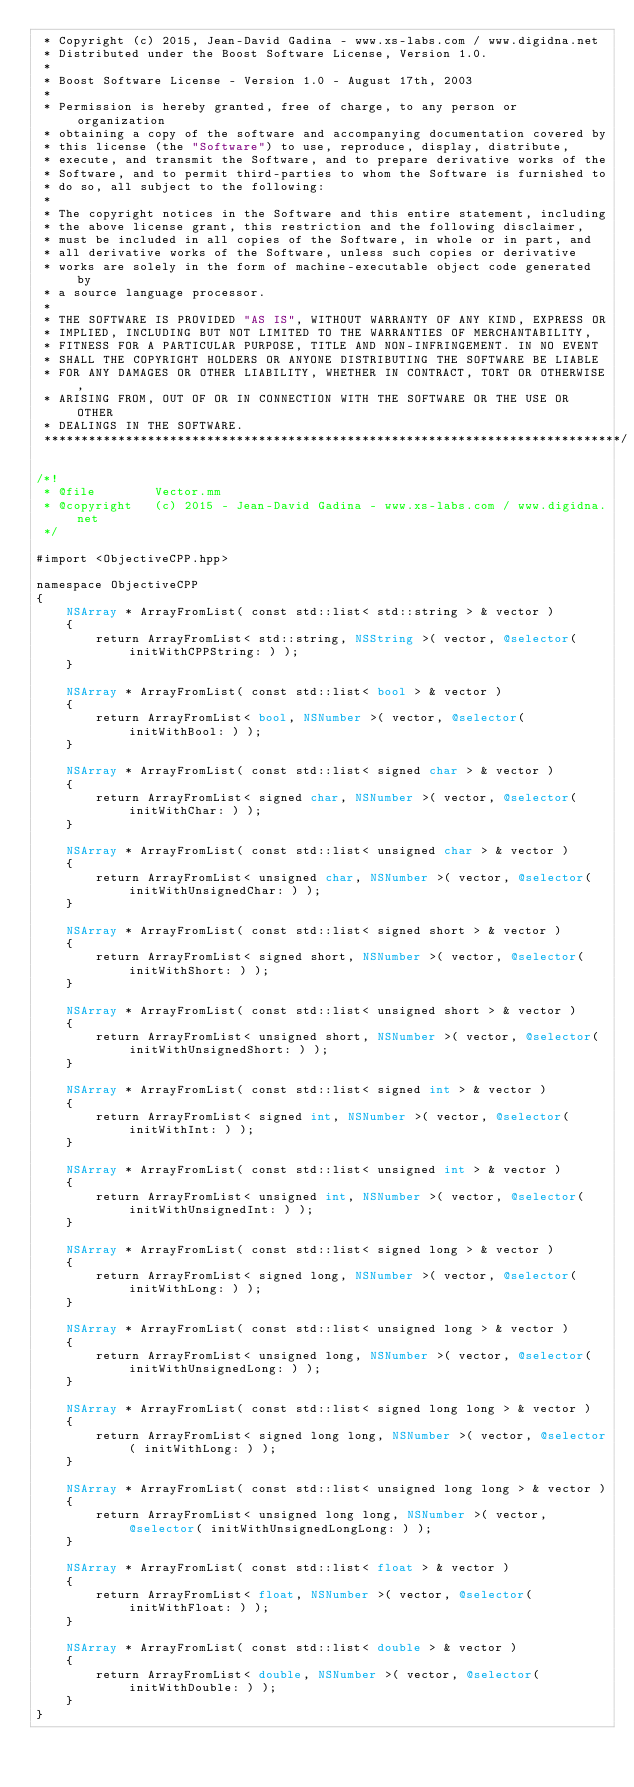<code> <loc_0><loc_0><loc_500><loc_500><_ObjectiveC_> * Copyright (c) 2015, Jean-David Gadina - www.xs-labs.com / www.digidna.net
 * Distributed under the Boost Software License, Version 1.0.
 * 
 * Boost Software License - Version 1.0 - August 17th, 2003
 * 
 * Permission is hereby granted, free of charge, to any person or organization
 * obtaining a copy of the software and accompanying documentation covered by
 * this license (the "Software") to use, reproduce, display, distribute,
 * execute, and transmit the Software, and to prepare derivative works of the
 * Software, and to permit third-parties to whom the Software is furnished to
 * do so, all subject to the following:
 * 
 * The copyright notices in the Software and this entire statement, including
 * the above license grant, this restriction and the following disclaimer,
 * must be included in all copies of the Software, in whole or in part, and
 * all derivative works of the Software, unless such copies or derivative
 * works are solely in the form of machine-executable object code generated by
 * a source language processor.
 * 
 * THE SOFTWARE IS PROVIDED "AS IS", WITHOUT WARRANTY OF ANY KIND, EXPRESS OR
 * IMPLIED, INCLUDING BUT NOT LIMITED TO THE WARRANTIES OF MERCHANTABILITY,
 * FITNESS FOR A PARTICULAR PURPOSE, TITLE AND NON-INFRINGEMENT. IN NO EVENT
 * SHALL THE COPYRIGHT HOLDERS OR ANYONE DISTRIBUTING THE SOFTWARE BE LIABLE
 * FOR ANY DAMAGES OR OTHER LIABILITY, WHETHER IN CONTRACT, TORT OR OTHERWISE,
 * ARISING FROM, OUT OF OR IN CONNECTION WITH THE SOFTWARE OR THE USE OR OTHER
 * DEALINGS IN THE SOFTWARE.
 ******************************************************************************/

/*!
 * @file        Vector.mm
 * @copyright   (c) 2015 - Jean-David Gadina - www.xs-labs.com / www.digidna.net
 */

#import <ObjectiveCPP.hpp>

namespace ObjectiveCPP
{
    NSArray * ArrayFromList( const std::list< std::string > & vector )
    {
        return ArrayFromList< std::string, NSString >( vector, @selector( initWithCPPString: ) );
    }
    
    NSArray * ArrayFromList( const std::list< bool > & vector )
    {
        return ArrayFromList< bool, NSNumber >( vector, @selector( initWithBool: ) );
    }
    
    NSArray * ArrayFromList( const std::list< signed char > & vector )
    {
        return ArrayFromList< signed char, NSNumber >( vector, @selector( initWithChar: ) );
    }
    
    NSArray * ArrayFromList( const std::list< unsigned char > & vector )
    {
        return ArrayFromList< unsigned char, NSNumber >( vector, @selector( initWithUnsignedChar: ) );
    }
    
    NSArray * ArrayFromList( const std::list< signed short > & vector )
    {
        return ArrayFromList< signed short, NSNumber >( vector, @selector( initWithShort: ) );
    }
    
    NSArray * ArrayFromList( const std::list< unsigned short > & vector )
    {
        return ArrayFromList< unsigned short, NSNumber >( vector, @selector( initWithUnsignedShort: ) );
    }
    
    NSArray * ArrayFromList( const std::list< signed int > & vector )
    {
        return ArrayFromList< signed int, NSNumber >( vector, @selector( initWithInt: ) );
    }
    
    NSArray * ArrayFromList( const std::list< unsigned int > & vector )
    {
        return ArrayFromList< unsigned int, NSNumber >( vector, @selector( initWithUnsignedInt: ) );
    }
    
    NSArray * ArrayFromList( const std::list< signed long > & vector )
    {
        return ArrayFromList< signed long, NSNumber >( vector, @selector( initWithLong: ) );
    }
    
    NSArray * ArrayFromList( const std::list< unsigned long > & vector )
    {
        return ArrayFromList< unsigned long, NSNumber >( vector, @selector( initWithUnsignedLong: ) );
    }
    
    NSArray * ArrayFromList( const std::list< signed long long > & vector )
    {
        return ArrayFromList< signed long long, NSNumber >( vector, @selector( initWithLong: ) );
    }
    
    NSArray * ArrayFromList( const std::list< unsigned long long > & vector )
    {
        return ArrayFromList< unsigned long long, NSNumber >( vector, @selector( initWithUnsignedLongLong: ) );
    }
    
    NSArray * ArrayFromList( const std::list< float > & vector )
    {
        return ArrayFromList< float, NSNumber >( vector, @selector( initWithFloat: ) );
    }
    
    NSArray * ArrayFromList( const std::list< double > & vector )
    {
        return ArrayFromList< double, NSNumber >( vector, @selector( initWithDouble: ) );
    }
}
</code> 